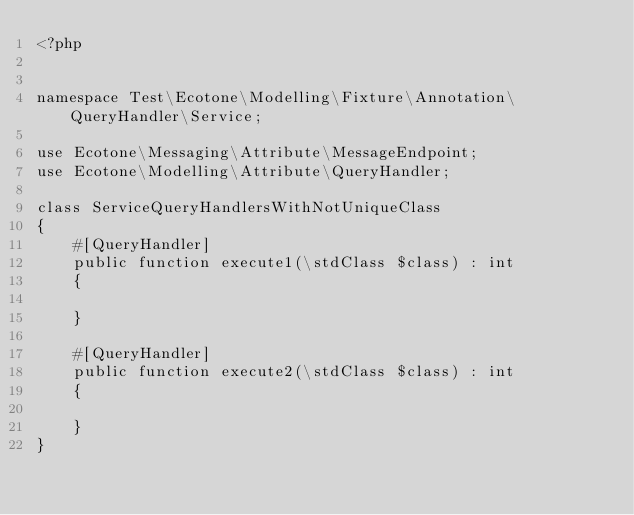Convert code to text. <code><loc_0><loc_0><loc_500><loc_500><_PHP_><?php


namespace Test\Ecotone\Modelling\Fixture\Annotation\QueryHandler\Service;

use Ecotone\Messaging\Attribute\MessageEndpoint;
use Ecotone\Modelling\Attribute\QueryHandler;

class ServiceQueryHandlersWithNotUniqueClass
{
    #[QueryHandler]
    public function execute1(\stdClass $class) : int
    {

    }

    #[QueryHandler]
    public function execute2(\stdClass $class) : int
    {

    }
}</code> 